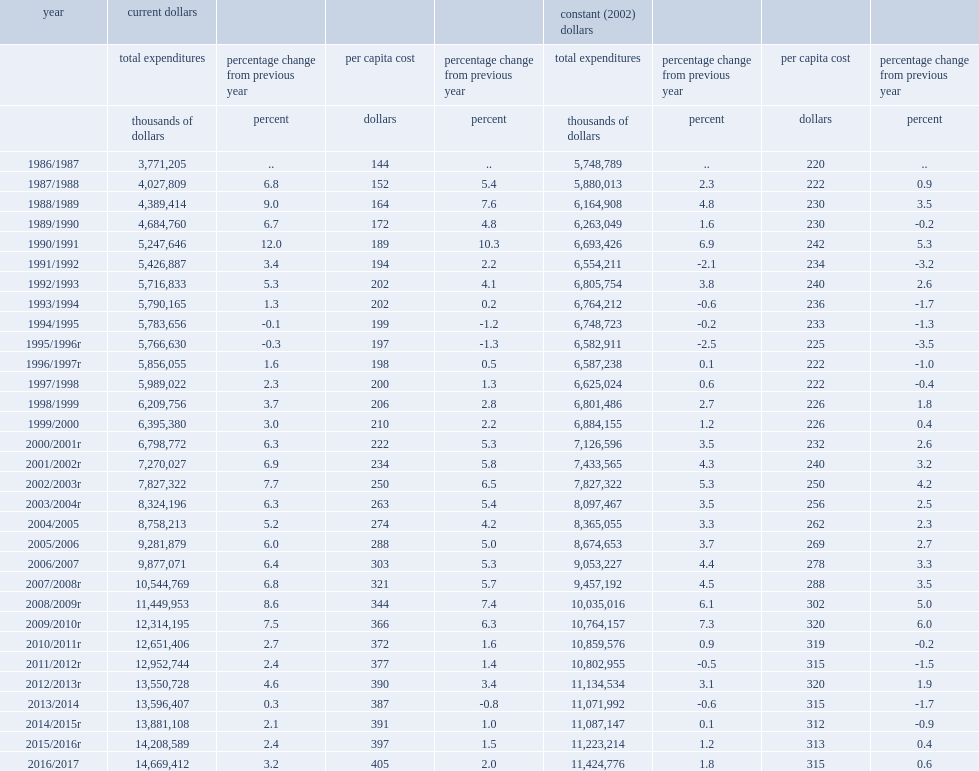Accounting for inflation, how many percent did total expenditures on policing in canada rise in 2016? 1.8. When did total expenditures on policing in constant dollars in canada decrease? 2011/2012r 2013/2014. Could you parse the entire table as a dict? {'header': ['year', 'current dollars', '', '', '', 'constant (2002) dollars', '', '', ''], 'rows': [['', 'total expenditures', 'percentage change from previous year', 'per capita cost', 'percentage change from previous year', 'total expenditures', 'percentage change from previous year', 'per capita cost', 'percentage change from previous year'], ['', 'thousands of dollars', 'percent', 'dollars', 'percent', 'thousands of dollars', 'percent', 'dollars', 'percent'], ['1986/1987', '3,771,205', '..', '144', '..', '5,748,789', '..', '220', '..'], ['1987/1988', '4,027,809', '6.8', '152', '5.4', '5,880,013', '2.3', '222', '0.9'], ['1988/1989', '4,389,414', '9.0', '164', '7.6', '6,164,908', '4.8', '230', '3.5'], ['1989/1990', '4,684,760', '6.7', '172', '4.8', '6,263,049', '1.6', '230', '-0.2'], ['1990/1991', '5,247,646', '12.0', '189', '10.3', '6,693,426', '6.9', '242', '5.3'], ['1991/1992', '5,426,887', '3.4', '194', '2.2', '6,554,211', '-2.1', '234', '-3.2'], ['1992/1993', '5,716,833', '5.3', '202', '4.1', '6,805,754', '3.8', '240', '2.6'], ['1993/1994', '5,790,165', '1.3', '202', '0.2', '6,764,212', '-0.6', '236', '-1.7'], ['1994/1995', '5,783,656', '-0.1', '199', '-1.2', '6,748,723', '-0.2', '233', '-1.3'], ['1995/1996r', '5,766,630', '-0.3', '197', '-1.3', '6,582,911', '-2.5', '225', '-3.5'], ['1996/1997r', '5,856,055', '1.6', '198', '0.5', '6,587,238', '0.1', '222', '-1.0'], ['1997/1998', '5,989,022', '2.3', '200', '1.3', '6,625,024', '0.6', '222', '-0.4'], ['1998/1999', '6,209,756', '3.7', '206', '2.8', '6,801,486', '2.7', '226', '1.8'], ['1999/2000', '6,395,380', '3.0', '210', '2.2', '6,884,155', '1.2', '226', '0.4'], ['2000/2001r', '6,798,772', '6.3', '222', '5.3', '7,126,596', '3.5', '232', '2.6'], ['2001/2002r', '7,270,027', '6.9', '234', '5.8', '7,433,565', '4.3', '240', '3.2'], ['2002/2003r', '7,827,322', '7.7', '250', '6.5', '7,827,322', '5.3', '250', '4.2'], ['2003/2004r', '8,324,196', '6.3', '263', '5.4', '8,097,467', '3.5', '256', '2.5'], ['2004/2005', '8,758,213', '5.2', '274', '4.2', '8,365,055', '3.3', '262', '2.3'], ['2005/2006', '9,281,879', '6.0', '288', '5.0', '8,674,653', '3.7', '269', '2.7'], ['2006/2007', '9,877,071', '6.4', '303', '5.3', '9,053,227', '4.4', '278', '3.3'], ['2007/2008r', '10,544,769', '6.8', '321', '5.7', '9,457,192', '4.5', '288', '3.5'], ['2008/2009r', '11,449,953', '8.6', '344', '7.4', '10,035,016', '6.1', '302', '5.0'], ['2009/2010r', '12,314,195', '7.5', '366', '6.3', '10,764,157', '7.3', '320', '6.0'], ['2010/2011r', '12,651,406', '2.7', '372', '1.6', '10,859,576', '0.9', '319', '-0.2'], ['2011/2012r', '12,952,744', '2.4', '377', '1.4', '10,802,955', '-0.5', '315', '-1.5'], ['2012/2013r', '13,550,728', '4.6', '390', '3.4', '11,134,534', '3.1', '320', '1.9'], ['2013/2014', '13,596,407', '0.3', '387', '-0.8', '11,071,992', '-0.6', '315', '-1.7'], ['2014/2015r', '13,881,108', '2.1', '391', '1.0', '11,087,147', '0.1', '312', '-0.9'], ['2015/2016r', '14,208,589', '2.4', '397', '1.5', '11,223,214', '1.2', '313', '0.4'], ['2016/2017', '14,669,412', '3.2', '405', '2.0', '11,424,776', '1.8', '315', '0.6']]} 